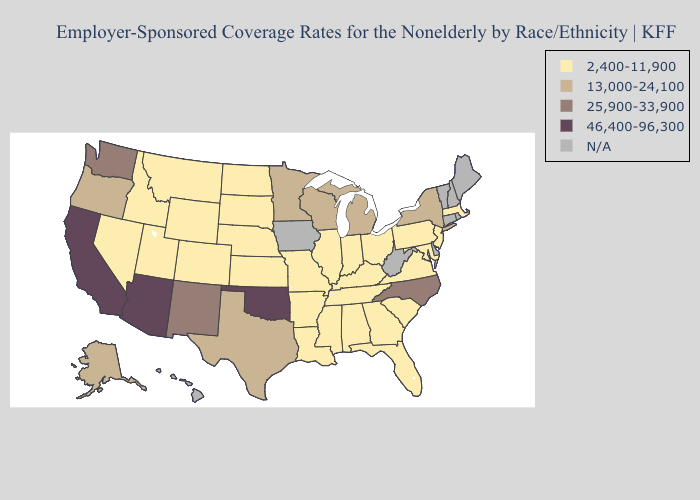Name the states that have a value in the range 25,900-33,900?
Give a very brief answer. New Mexico, North Carolina, Washington. Does New Jersey have the lowest value in the Northeast?
Short answer required. Yes. What is the highest value in the USA?
Concise answer only. 46,400-96,300. Name the states that have a value in the range 25,900-33,900?
Keep it brief. New Mexico, North Carolina, Washington. Among the states that border Iowa , does Minnesota have the highest value?
Short answer required. Yes. Name the states that have a value in the range 13,000-24,100?
Quick response, please. Alaska, Michigan, Minnesota, New York, Oregon, Texas, Wisconsin. Name the states that have a value in the range N/A?
Concise answer only. Connecticut, Delaware, Hawaii, Iowa, Maine, New Hampshire, Rhode Island, Vermont, West Virginia. What is the value of Pennsylvania?
Quick response, please. 2,400-11,900. Does Oklahoma have the highest value in the USA?
Give a very brief answer. Yes. Name the states that have a value in the range 25,900-33,900?
Concise answer only. New Mexico, North Carolina, Washington. What is the lowest value in the USA?
Short answer required. 2,400-11,900. Among the states that border Pennsylvania , does Maryland have the lowest value?
Write a very short answer. Yes. What is the value of Connecticut?
Quick response, please. N/A. 